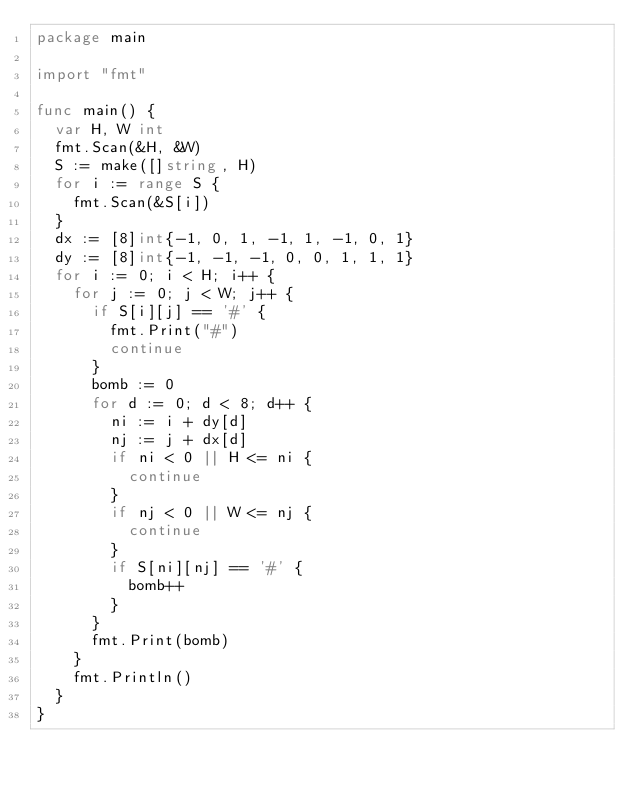<code> <loc_0><loc_0><loc_500><loc_500><_Go_>package main

import "fmt"

func main() {
	var H, W int
	fmt.Scan(&H, &W)
	S := make([]string, H)
	for i := range S {
		fmt.Scan(&S[i])
	}
	dx := [8]int{-1, 0, 1, -1, 1, -1, 0, 1}
	dy := [8]int{-1, -1, -1, 0, 0, 1, 1, 1}
	for i := 0; i < H; i++ {
		for j := 0; j < W; j++ {
			if S[i][j] == '#' {
				fmt.Print("#")
				continue
			}
			bomb := 0
			for d := 0; d < 8; d++ {
				ni := i + dy[d]
				nj := j + dx[d]
				if ni < 0 || H <= ni {
					continue
				}
				if nj < 0 || W <= nj {
					continue
				}
				if S[ni][nj] == '#' {
					bomb++
				}
			}
			fmt.Print(bomb)
		}
		fmt.Println()
	}
}
</code> 